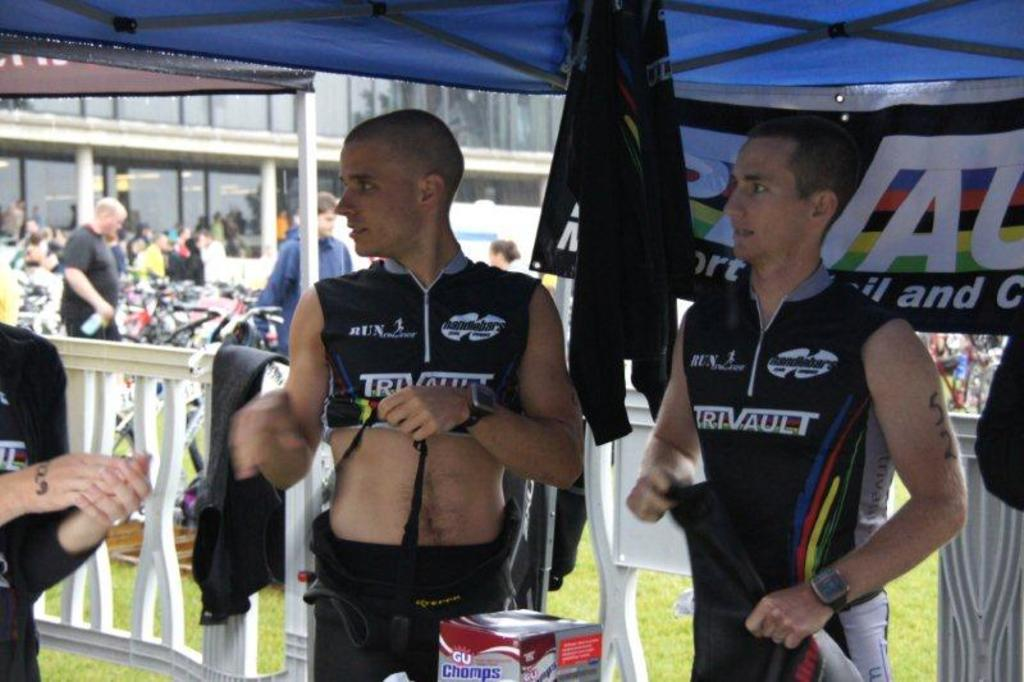<image>
Create a compact narrative representing the image presented. a couple guys with trtvault on their shirts 